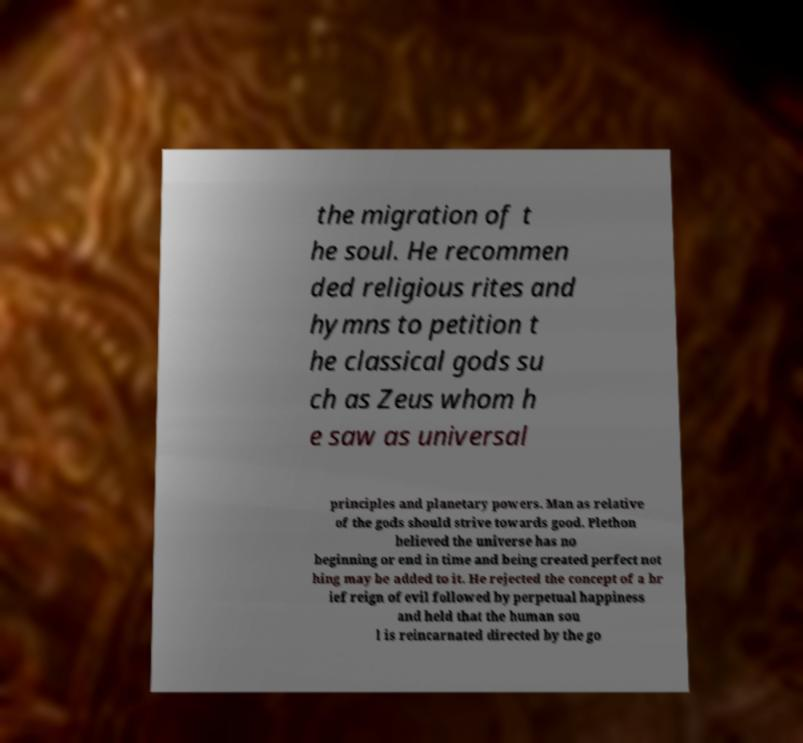Could you assist in decoding the text presented in this image and type it out clearly? the migration of t he soul. He recommen ded religious rites and hymns to petition t he classical gods su ch as Zeus whom h e saw as universal principles and planetary powers. Man as relative of the gods should strive towards good. Plethon believed the universe has no beginning or end in time and being created perfect not hing may be added to it. He rejected the concept of a br ief reign of evil followed by perpetual happiness and held that the human sou l is reincarnated directed by the go 